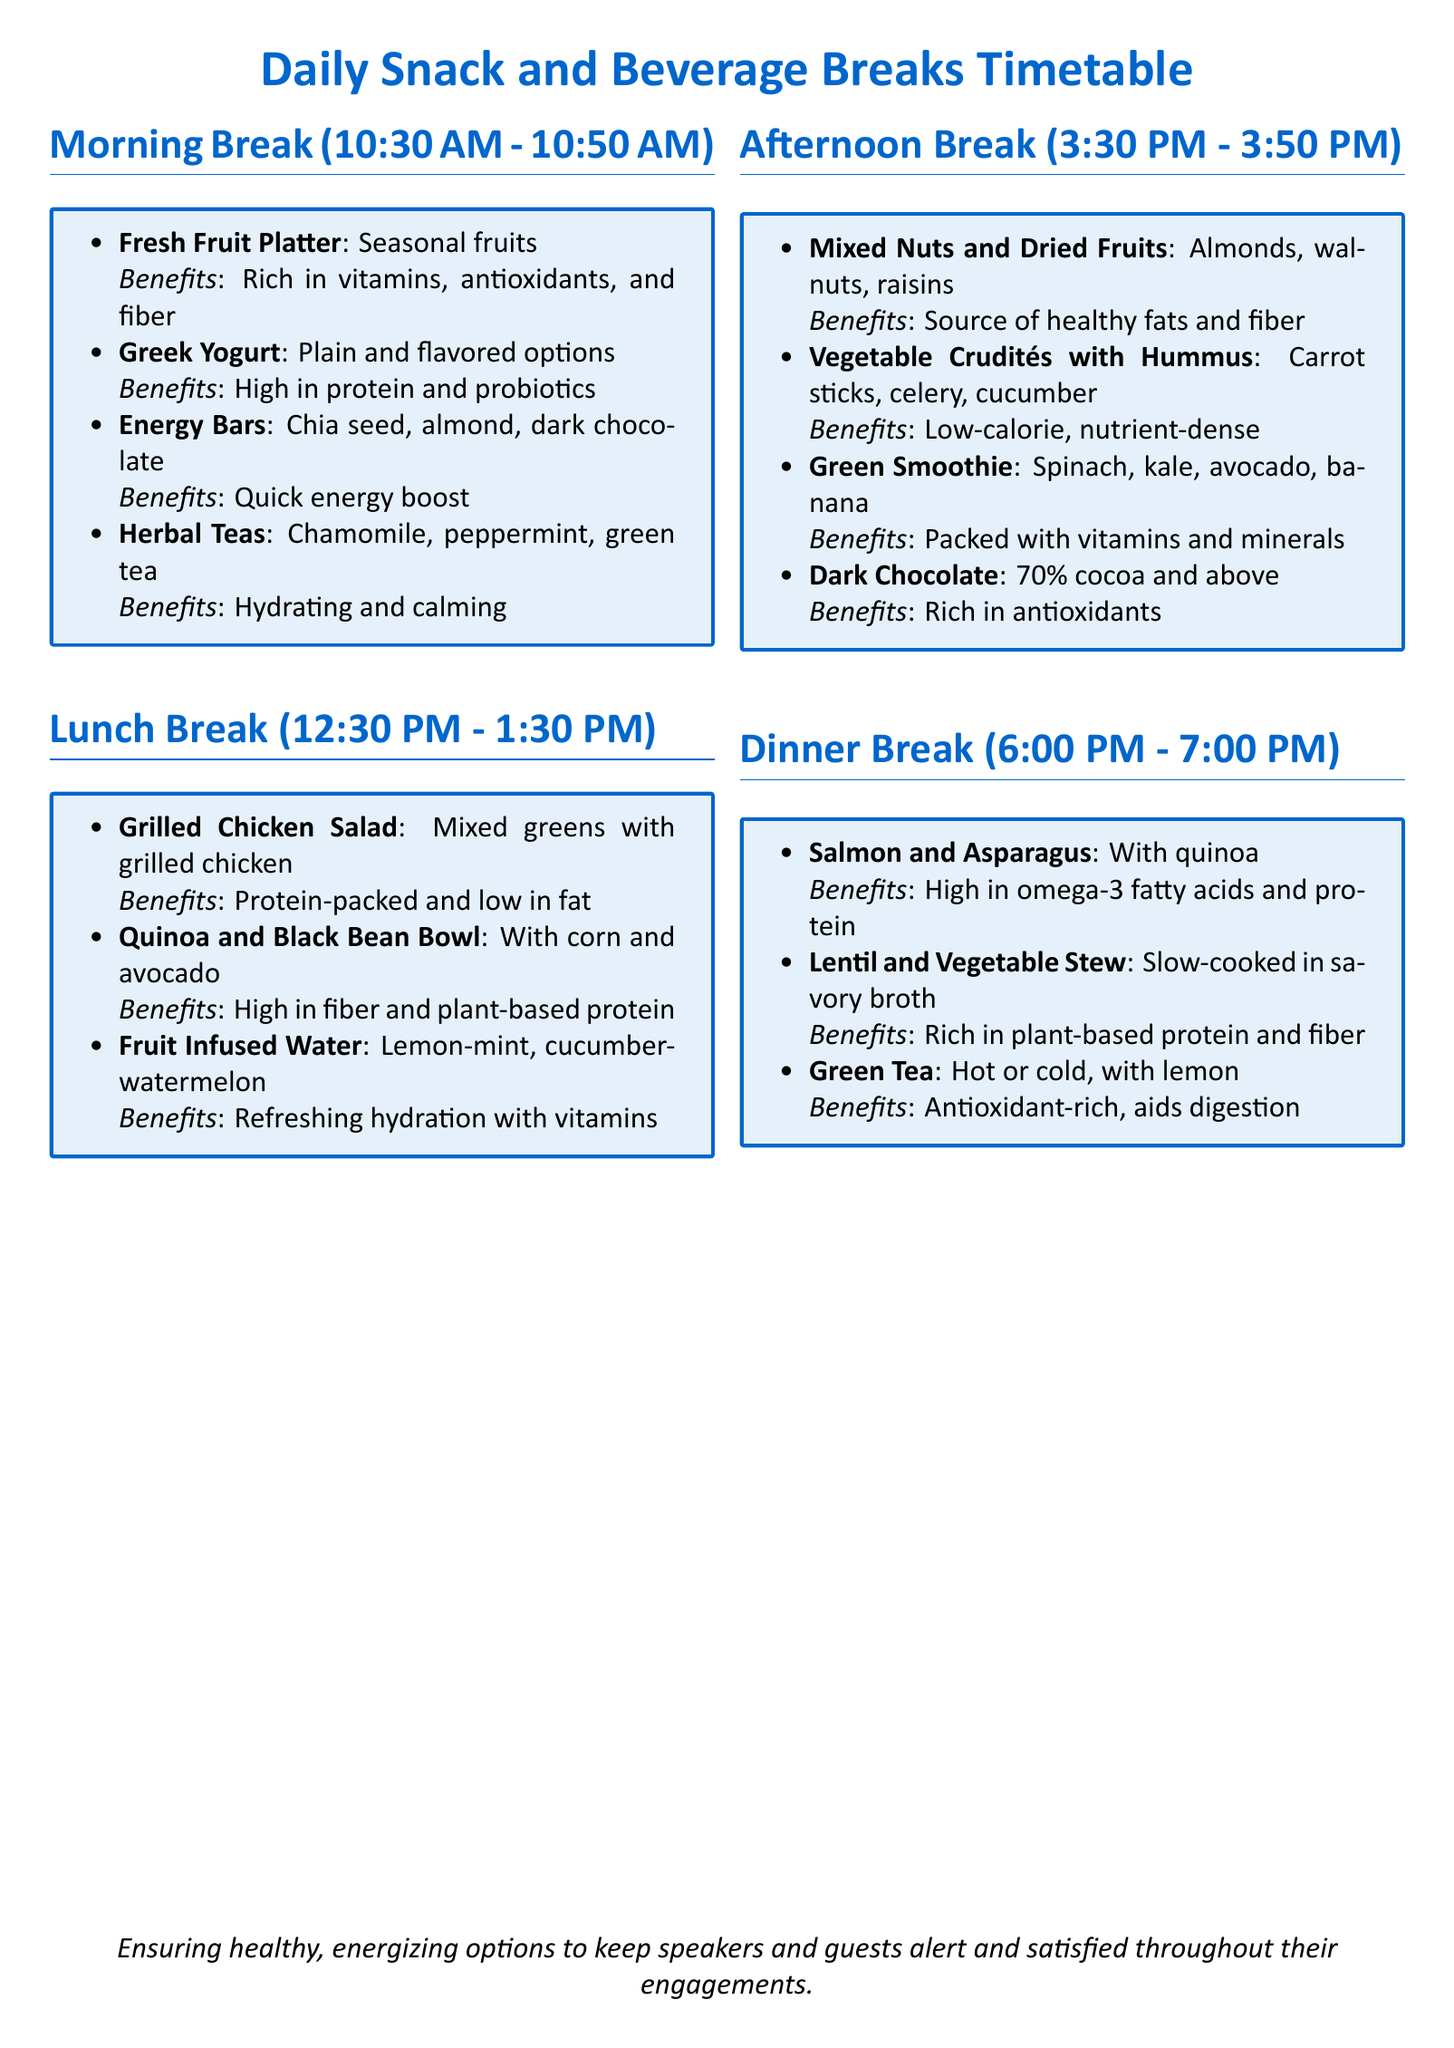What time does the morning break start? The morning break starts at 10:30 AM as mentioned in the timetable.
Answer: 10:30 AM What type of beverage is offered during the afternoon break? The afternoon break includes dark chocolate as a snack, but it also contains beverages such as herbal teas during the morning and green tea during the dinner break.
Answer: Herbal Teas How long is the lunch break scheduled for? The lunch break is set for one hour, from 12:30 PM to 1:30 PM, which is indicated in the document.
Answer: 1 hour What is one benefit of eating a mixed nut and dried fruit snack? The mixed nuts and dried fruits provide a source of healthy fats and fiber, which is listed under benefits in the timetable.
Answer: Healthy fats and fiber Which item is labeled as rich in omega-3 fatty acids? The document specifies that salmon and asparagus is high in omega-3 fatty acids in the dinner break section.
Answer: Salmon and Asparagus What is an energizing choice offered in the morning break? The energy bars made with chia seed, almond, and dark chocolate are specified as a quick energy boost during the morning break.
Answer: Energy Bars How many items are listed for the afternoon break? There are four items listed for the afternoon break in the timetable, as outlined in the document.
Answer: 4 items What type of water is provided during lunch? The document mentions fruit infused water as a beverage option during the lunch break.
Answer: Fruit Infused Water 